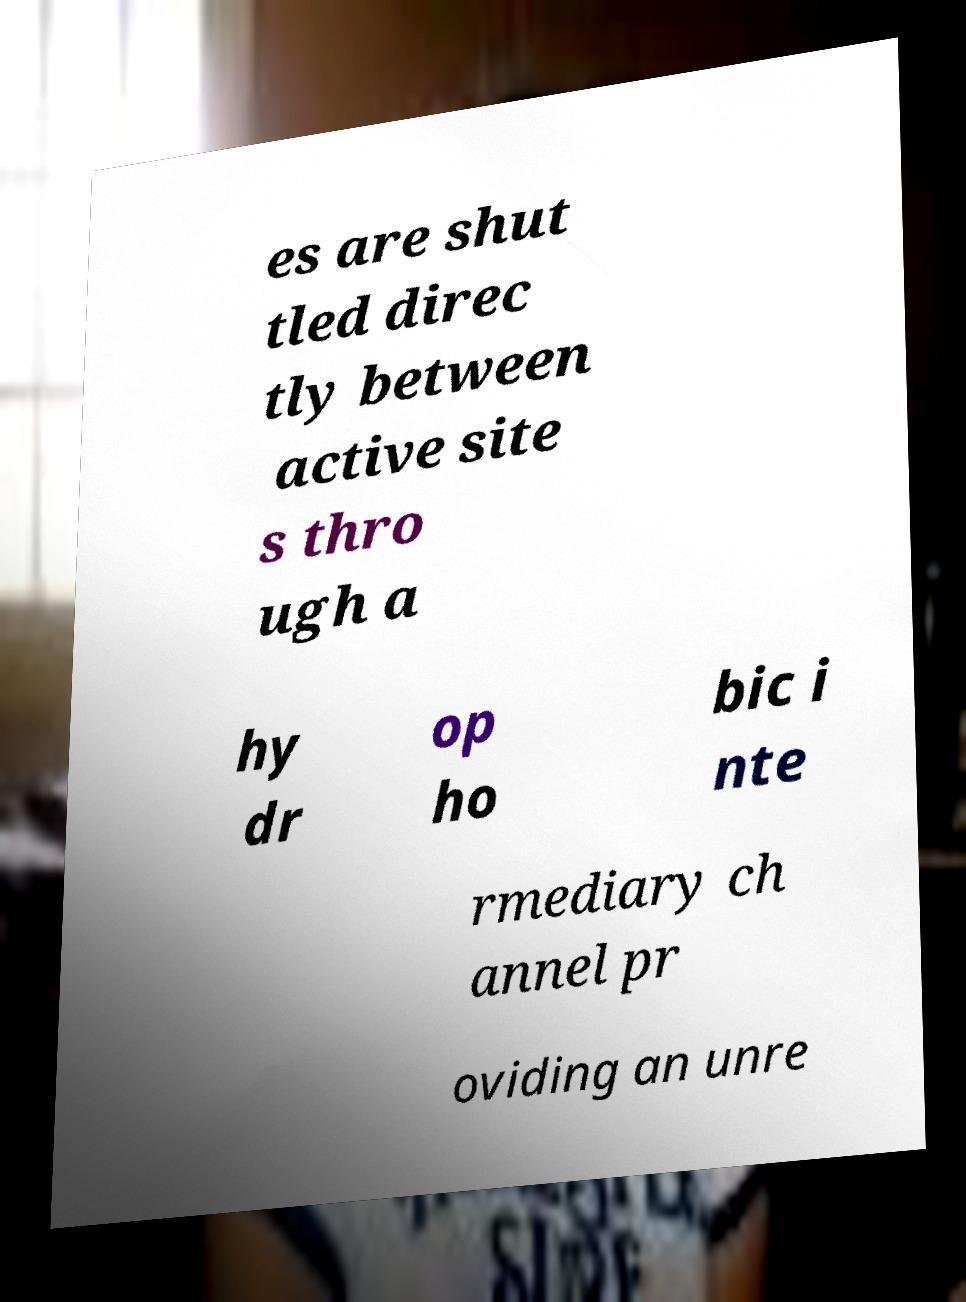I need the written content from this picture converted into text. Can you do that? es are shut tled direc tly between active site s thro ugh a hy dr op ho bic i nte rmediary ch annel pr oviding an unre 